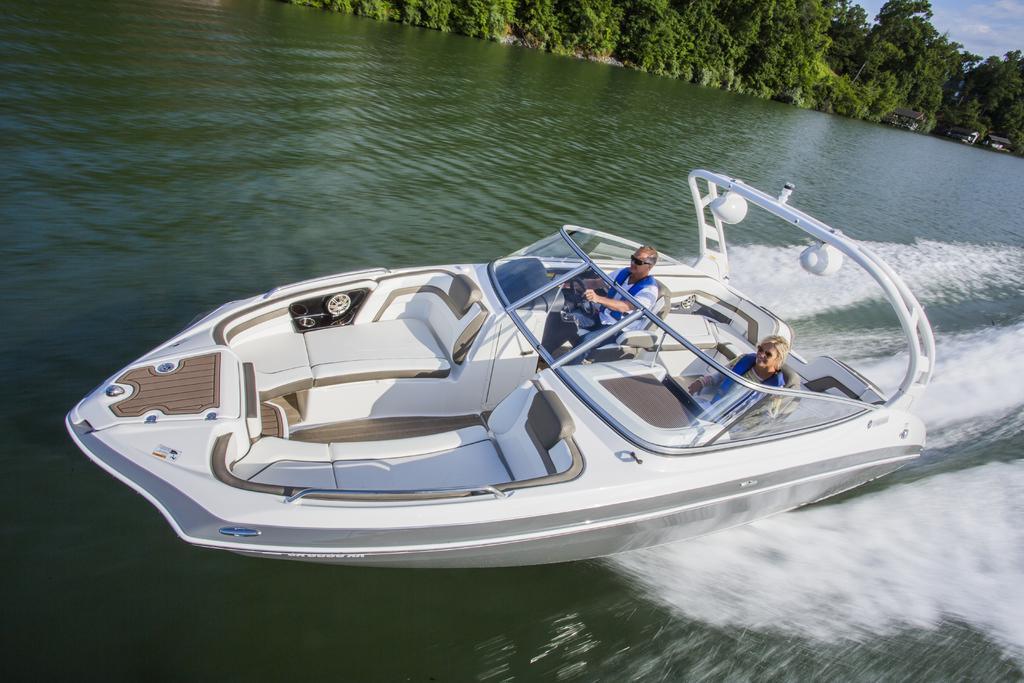How would you summarize this image in a sentence or two? In this image there is a board sailing on water. Two persons are sitting in the boat. A person is holding the steering of the boat. They are wearing jackets. Top of image there are few houses. Behind there are few trees and sky. 